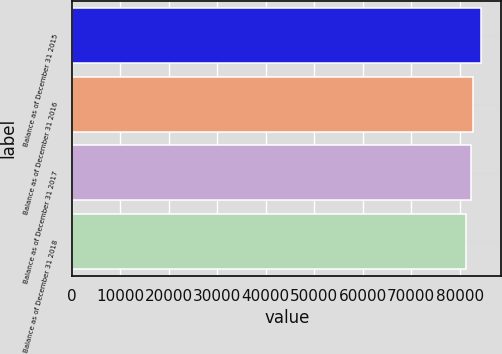Convert chart. <chart><loc_0><loc_0><loc_500><loc_500><bar_chart><fcel>Balance as of December 31 2015<fcel>Balance as of December 31 2016<fcel>Balance as of December 31 2017<fcel>Balance as of December 31 2018<nl><fcel>84412<fcel>82694.1<fcel>82376<fcel>81231<nl></chart> 